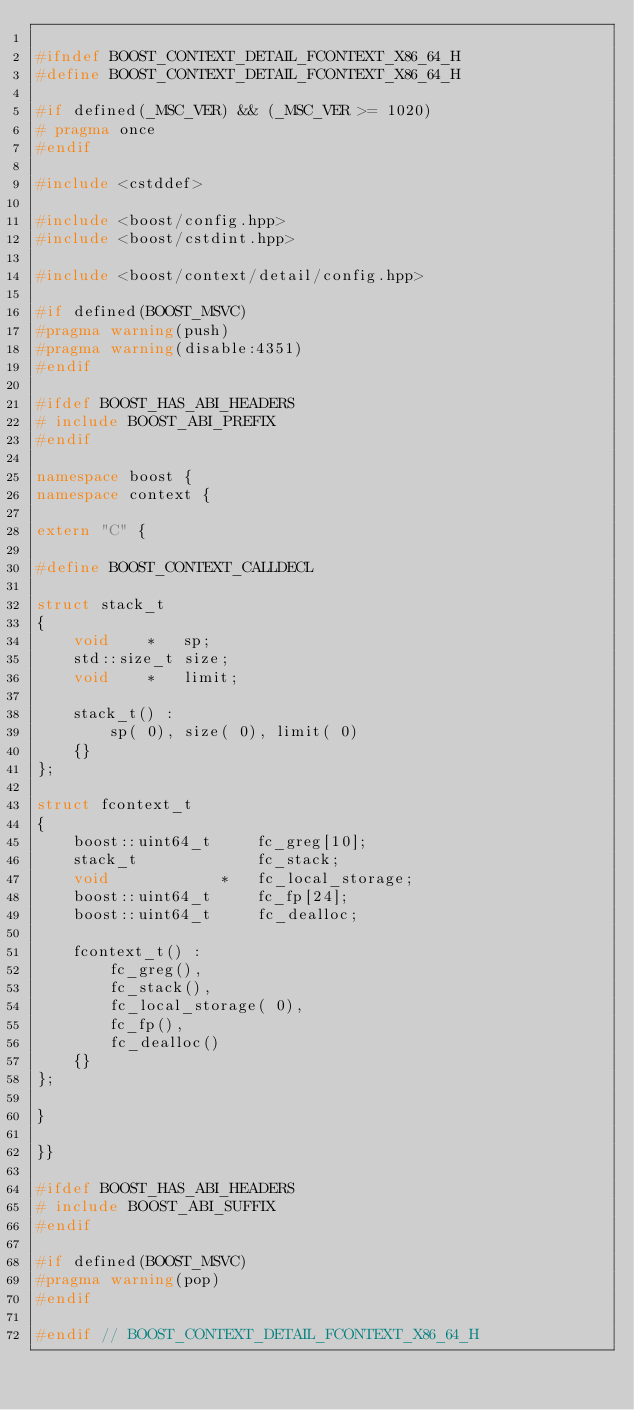Convert code to text. <code><loc_0><loc_0><loc_500><loc_500><_C++_>
#ifndef BOOST_CONTEXT_DETAIL_FCONTEXT_X86_64_H
#define BOOST_CONTEXT_DETAIL_FCONTEXT_X86_64_H

#if defined(_MSC_VER) && (_MSC_VER >= 1020)
# pragma once
#endif

#include <cstddef>

#include <boost/config.hpp>
#include <boost/cstdint.hpp>

#include <boost/context/detail/config.hpp>

#if defined(BOOST_MSVC)
#pragma warning(push)
#pragma warning(disable:4351)
#endif

#ifdef BOOST_HAS_ABI_HEADERS
# include BOOST_ABI_PREFIX
#endif

namespace boost {
namespace context {

extern "C" {

#define BOOST_CONTEXT_CALLDECL

struct stack_t
{
    void    *   sp;
    std::size_t size;
    void    *   limit;

    stack_t() :
        sp( 0), size( 0), limit( 0)
    {}
};

struct fcontext_t
{
    boost::uint64_t     fc_greg[10];
    stack_t             fc_stack;
    void            *   fc_local_storage;
    boost::uint64_t     fc_fp[24];
    boost::uint64_t     fc_dealloc;

    fcontext_t() :
        fc_greg(),
        fc_stack(),
        fc_local_storage( 0),
        fc_fp(),
        fc_dealloc()
    {}
};

}

}}

#ifdef BOOST_HAS_ABI_HEADERS
# include BOOST_ABI_SUFFIX
#endif

#if defined(BOOST_MSVC)
#pragma warning(pop)
#endif

#endif // BOOST_CONTEXT_DETAIL_FCONTEXT_X86_64_H
</code> 